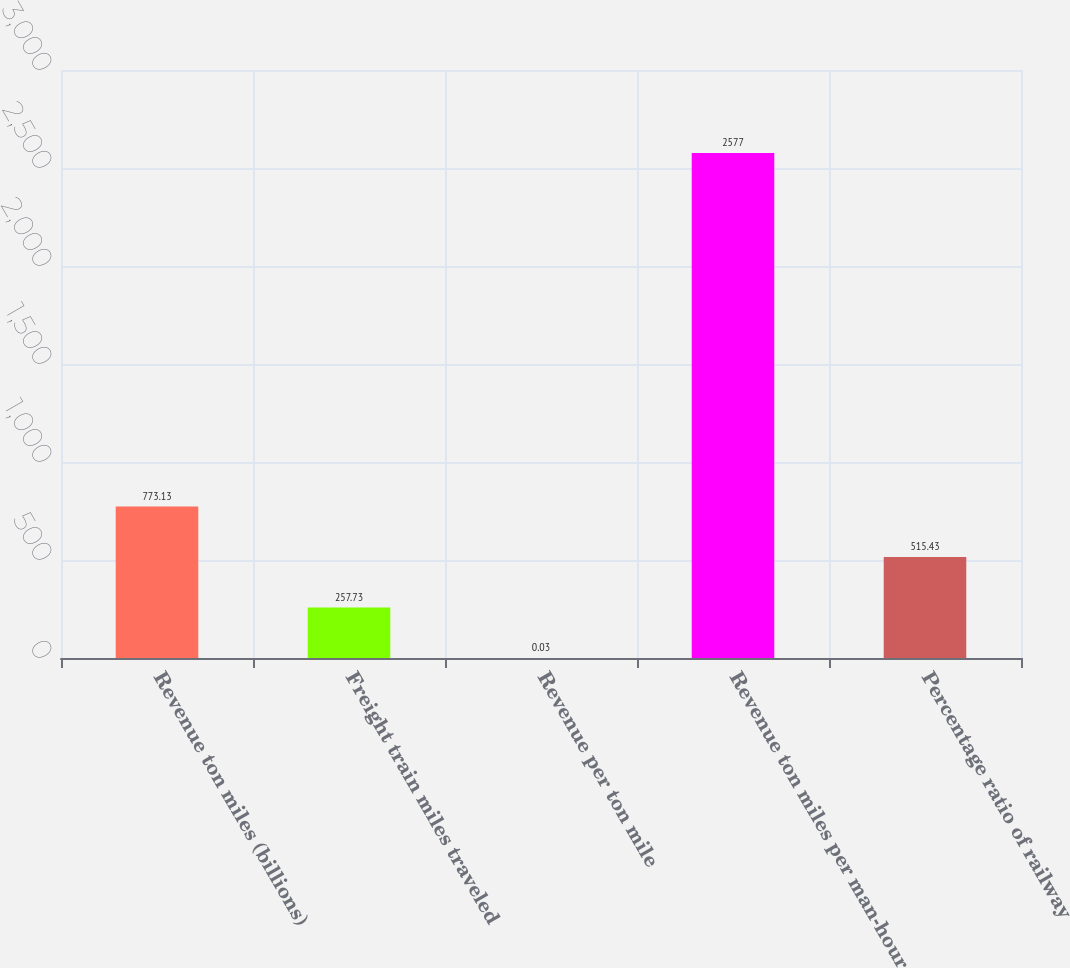Convert chart. <chart><loc_0><loc_0><loc_500><loc_500><bar_chart><fcel>Revenue ton miles (billions)<fcel>Freight train miles traveled<fcel>Revenue per ton mile<fcel>Revenue ton miles per man-hour<fcel>Percentage ratio of railway<nl><fcel>773.13<fcel>257.73<fcel>0.03<fcel>2577<fcel>515.43<nl></chart> 